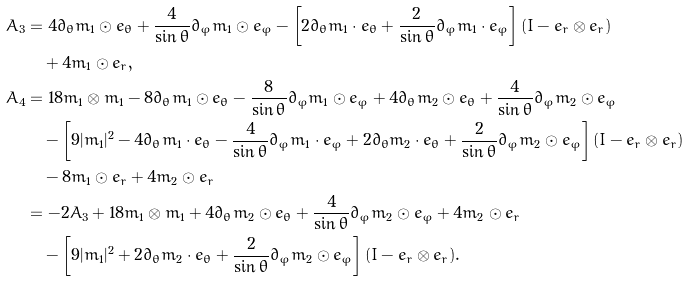<formula> <loc_0><loc_0><loc_500><loc_500>A _ { 3 } & = 4 \partial _ { \theta } m _ { 1 } \odot e _ { \theta } + \frac { 4 } { \sin \theta } \partial _ { \varphi } m _ { 1 } \odot e _ { \varphi } - \left [ 2 \partial _ { \theta } m _ { 1 } \cdot e _ { \theta } + \frac { 2 } { \sin \theta } \partial _ { \varphi } m _ { 1 } \cdot e _ { \varphi } \right ] ( I - e _ { r } \otimes e _ { r } ) \\ & \quad + 4 m _ { 1 } \odot e _ { r } , \\ A _ { 4 } & = 1 8 m _ { 1 } \otimes m _ { 1 } - 8 \partial _ { \theta } m _ { 1 } \odot e _ { \theta } - \frac { 8 } { \sin \theta } \partial _ { \varphi } m _ { 1 } \odot e _ { \varphi } + 4 \partial _ { \theta } m _ { 2 } \odot e _ { \theta } + \frac { 4 } { \sin \theta } \partial _ { \varphi } m _ { 2 } \odot e _ { \varphi } \\ & \quad - \left [ 9 | m _ { 1 } | ^ { 2 } - 4 \partial _ { \theta } m _ { 1 } \cdot e _ { \theta } - \frac { 4 } { \sin \theta } \partial _ { \varphi } m _ { 1 } \cdot e _ { \varphi } + 2 \partial _ { \theta } m _ { 2 } \cdot e _ { \theta } + \frac { 2 } { \sin \theta } \partial _ { \varphi } m _ { 2 } \odot e _ { \varphi } \right ] ( I - e _ { r } \otimes e _ { r } ) \\ & \quad - 8 m _ { 1 } \odot e _ { r } + 4 m _ { 2 } \odot e _ { r } \\ & = - 2 A _ { 3 } + 1 8 m _ { 1 } \otimes m _ { 1 } + 4 \partial _ { \theta } m _ { 2 } \odot e _ { \theta } + \frac { 4 } { \sin \theta } \partial _ { \varphi } m _ { 2 } \odot e _ { \varphi } + 4 m _ { 2 } \odot e _ { r } \\ & \quad - \left [ 9 | m _ { 1 } | ^ { 2 } + 2 \partial _ { \theta } m _ { 2 } \cdot e _ { \theta } + \frac { 2 } { \sin \theta } \partial _ { \varphi } m _ { 2 } \odot e _ { \varphi } \right ] ( I - e _ { r } \otimes e _ { r } ) .</formula> 